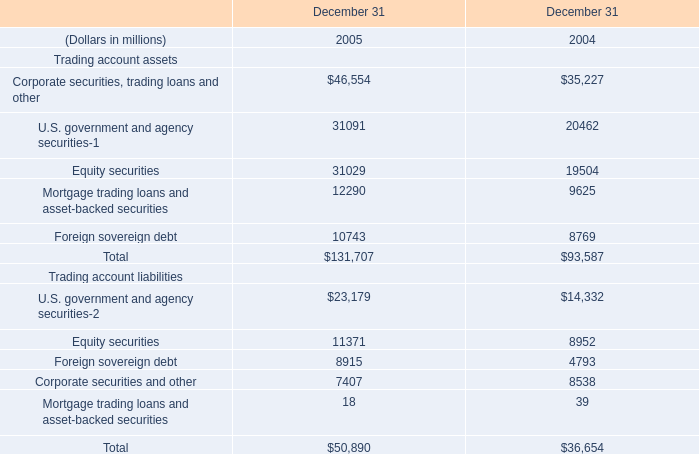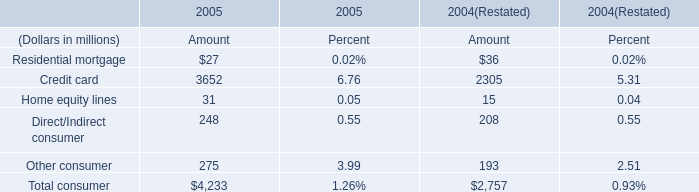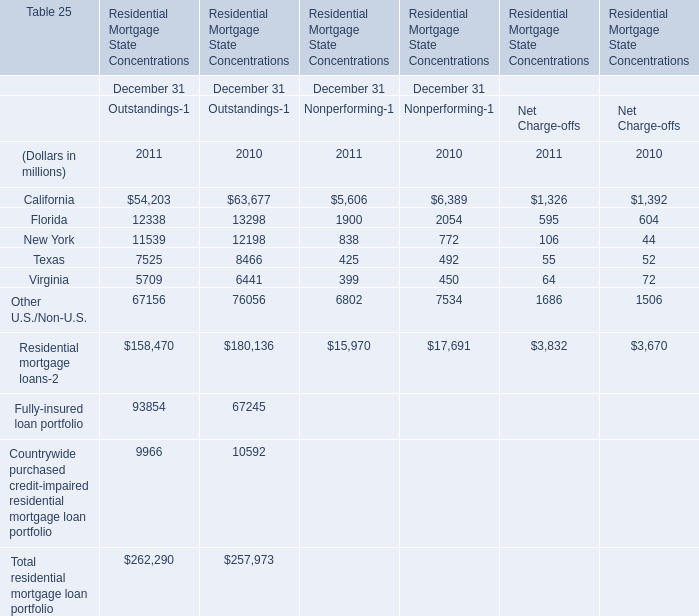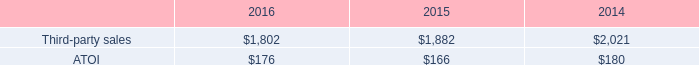Without Residential mortgage loans and Fully-insured loan portfolio, how much of Outstandings is there in total in 2011? (in million) 
Answer: 9966. 